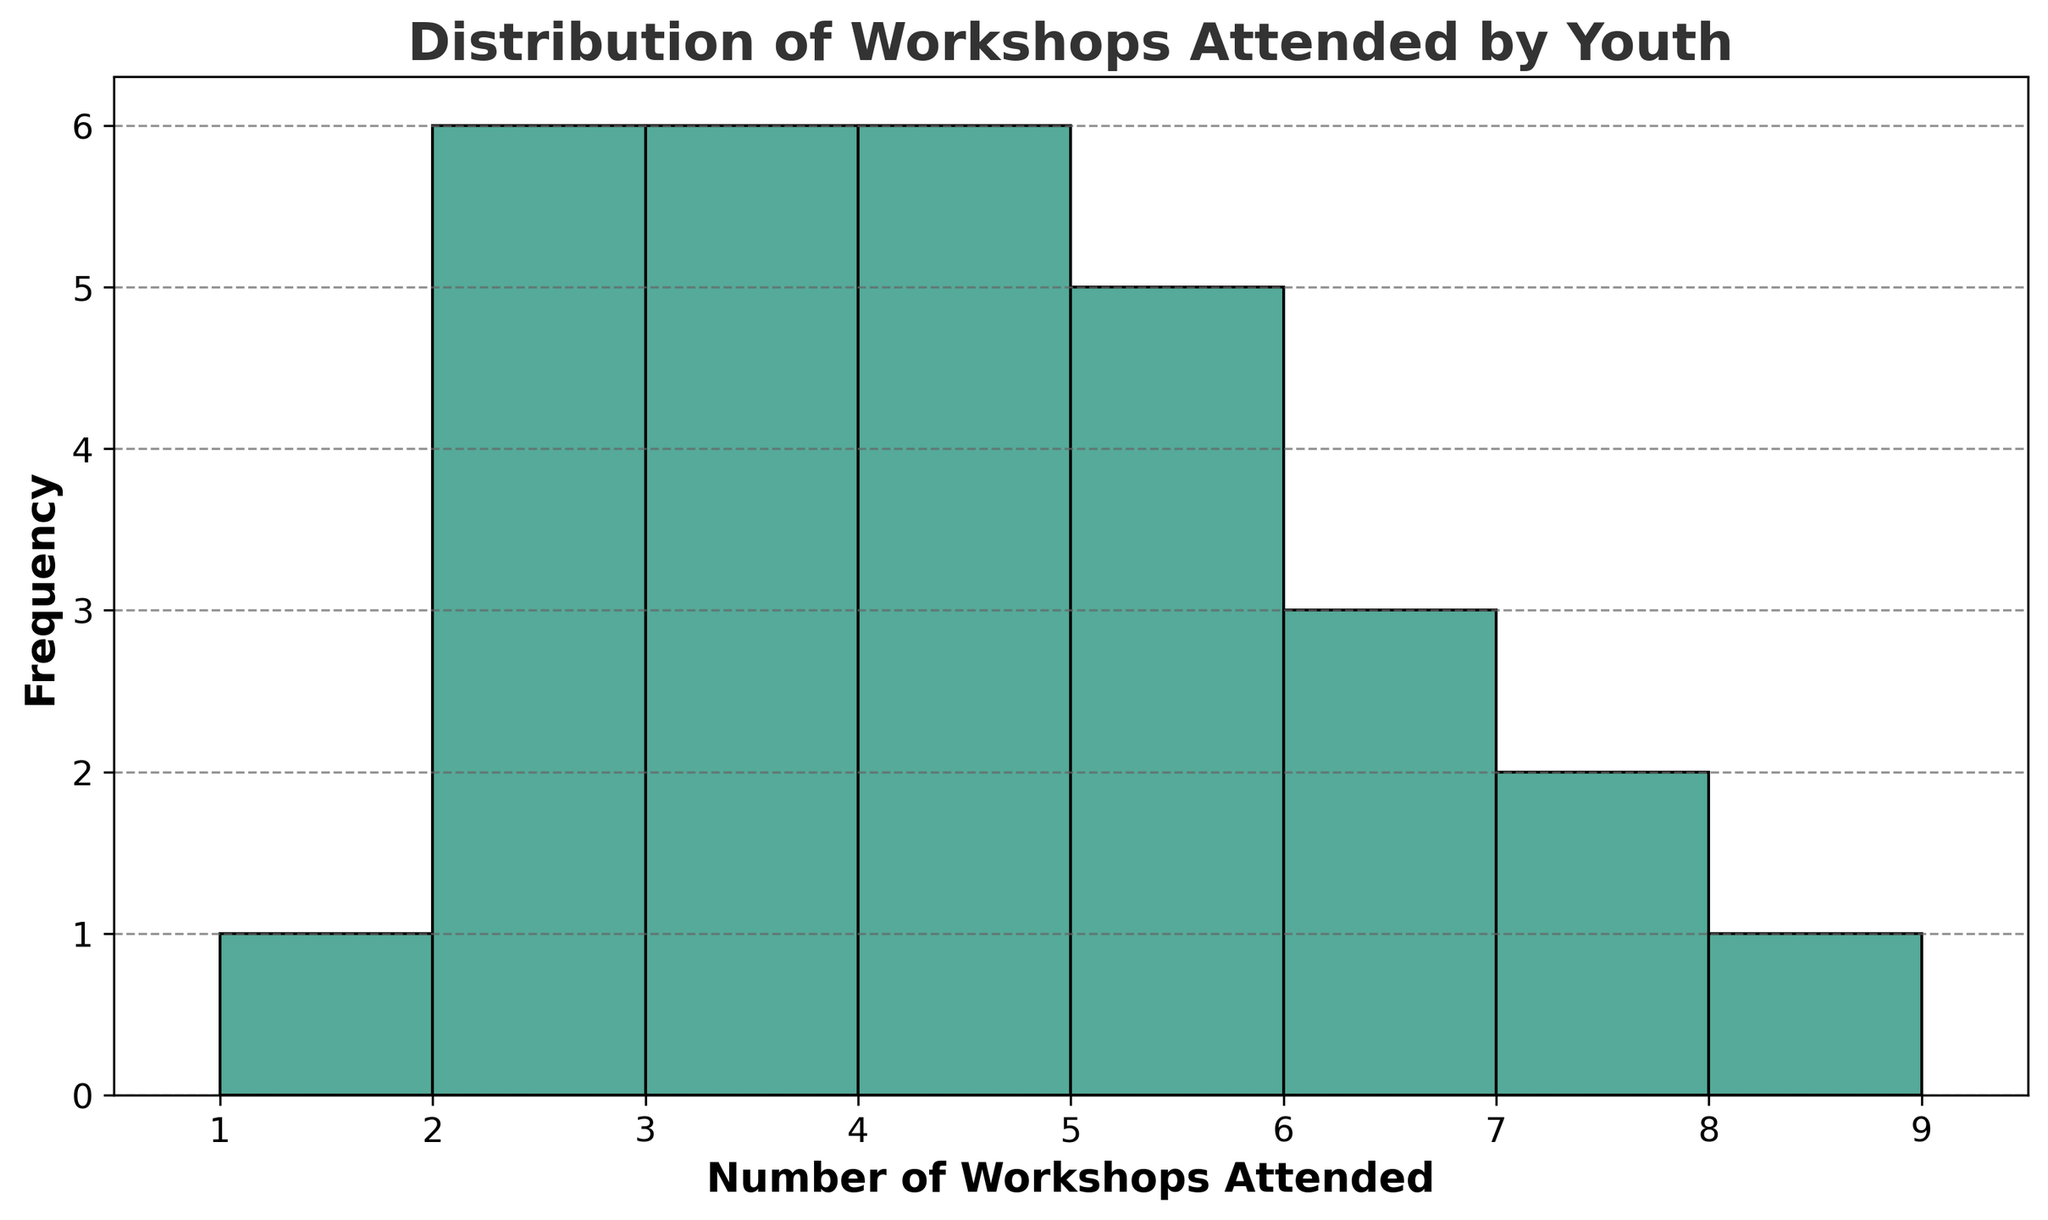What is the most frequent number of workshops attended? The tallest bar in the histogram indicates the most frequent number of workshops attended. By looking at the tallest bar and its corresponding value on the x-axis, we can determine this frequency.
Answer: 3 What is the least frequent number of workshops attended? The shortest bars in the histogram indicate the least frequent number of workshops attended. By identifying the shortest bars and their corresponding values on the x-axis, we can determine the least frequent counts.
Answer: 7 and 8 How many people attended exactly 4 workshops? Look at the height of the bar corresponding to "4" on the x-axis. The height of this bar indicates the number of people who attended exactly 4 workshops.
Answer: 4 Which number of workshops attended is more common: 2 or 6? Compare the height of the bars corresponding to "2" and "6" on the x-axis. The taller bar indicates the more common number of workshops attended.
Answer: 2 What is the total number of people who attended 2 and 3 workshops combined? Identify the heights of the bars corresponding to "2" and "3" on the x-axis and sum them up. The height of each bar represents the number of people who attended that many workshops. The bar for "2" is 5 and for "3" is 4. Summing these gives 9.
Answer: 9 What is the average number of workshops attended? Compute the average by summing the product of the number of workshops attended and their frequencies, then divide by the total number of people. The total is 96 and the number of participants is 30. So, the average is 96/30.
Answer: 3.2 Is the distribution of workshops attended more skewed towards higher or lower numbers? Assess the shape of the histogram. If most bars with significant height are toward lower numbers, it's skewed toward lower numbers, and vice versa.
Answer: Lower How many more people attended 4 workshops compared to 1 workshop? Identify the heights of bars for "4" and "1". The height of the bar for "4" is 4, and for "1" is 0. Therefore, the difference is 4 - 0.
Answer: 4 What's the difference in frequency between the most and least attended workshops? Determine the heights of the tallest and shortest bars, then compute their difference. The tallest bar (3 workshops) is 5, and the shortest (7 and 8 workshops) is 1. Therefore, the difference is 4.
Answer: 4 